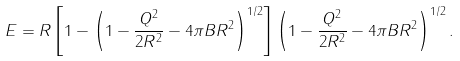<formula> <loc_0><loc_0><loc_500><loc_500>E = R \left [ 1 - \left ( 1 - \frac { Q ^ { 2 } } { 2 R ^ { 2 } } - 4 \pi B R ^ { 2 } \right ) ^ { 1 / 2 } \right ] \left ( 1 - \frac { Q ^ { 2 } } { 2 R ^ { 2 } } - 4 \pi B R ^ { 2 } \right ) ^ { 1 / 2 } .</formula> 